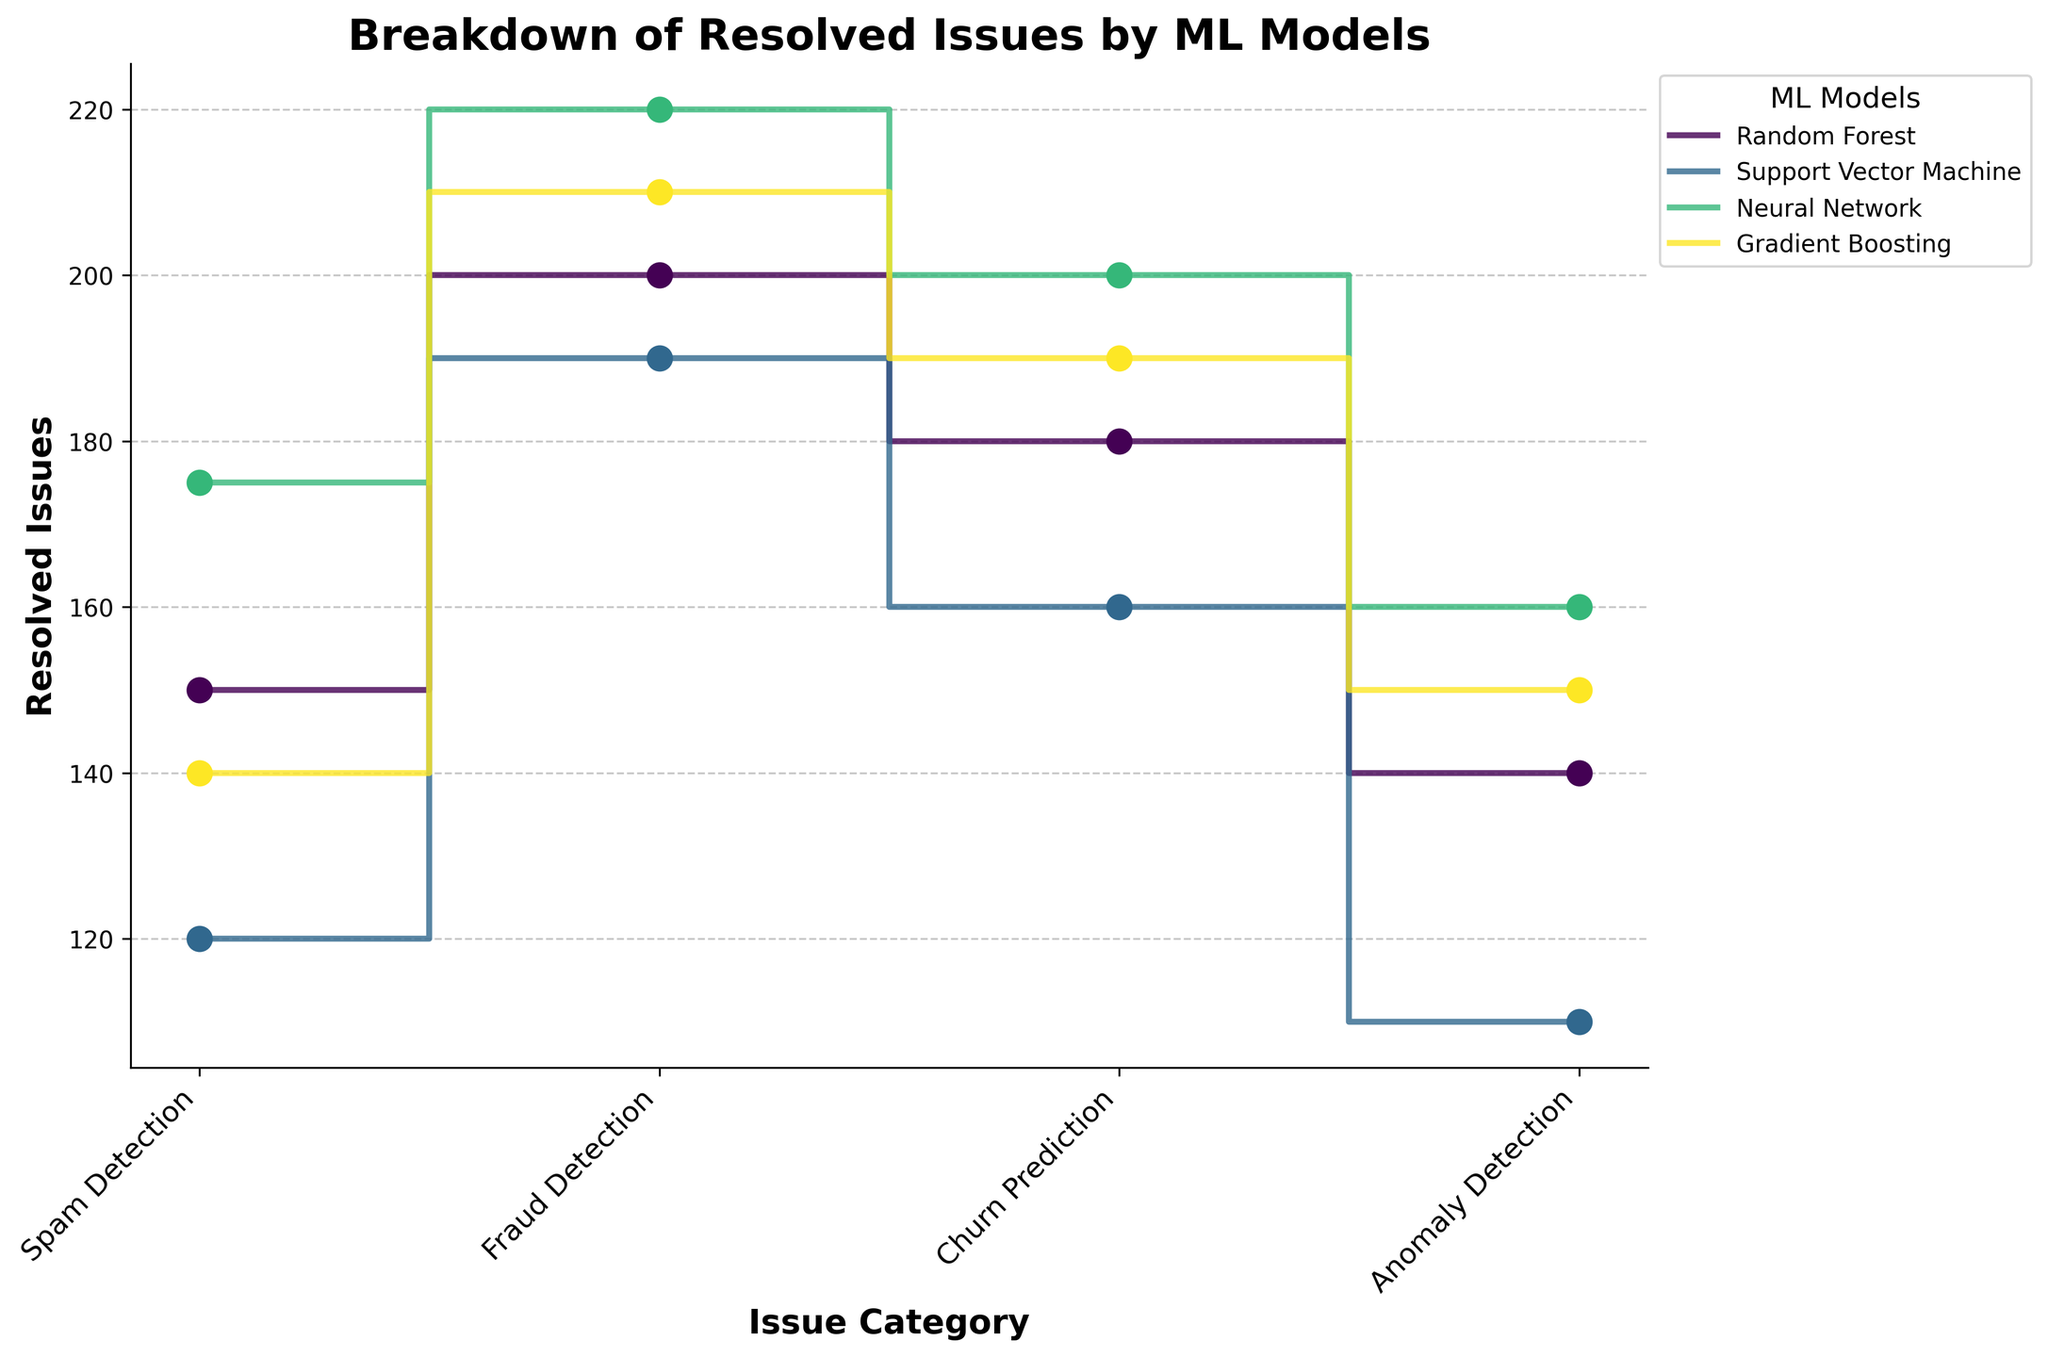What is the title of the figure? Look at the top center of the figure for the title.
Answer: Breakdown of Resolved Issues by ML Models Which machine learning model resolved the most spam detection issues? Compare the resolved spam detection issues for all models.
Answer: Neural Network How many resolved issues does the Support Vector Machine have for anomaly detection? Look at the step plot for Support Vector Machine and check the resolved issue count at the anomaly detection point.
Answer: 110 What is the total number of issues resolved by Gradient Boosting across all categories? Sum the resolved issues for Gradient Boosting in all categories (Spam Detection + Fraud Detection + Churn Prediction + Anomaly Detection).
Answer: 140 + 210 + 190 + 150 = 690 Which two models have resolved the same number of issues for spam detection? Check the step plots for spam detection across all models and identify any overlaps.
Answer: Random Forest and Gradient Boosting In which category does the Neural Network perform better than all other models? Compare the resolved issues for Neural Network with other models in each category.
Answer: Fraud Detection What is the difference in resolved fraud detection issues between Random Forest and Support Vector Machine? Subtract Support Vector Machine's fraud detection issues from Random Forest's fraud detection issues.
Answer: 200 - 190 = 10 If you sum the resolved issues for anomaly detection across all models, what is the total? Add the resolved issues for anomaly detection for all models.
Answer: 140 + 110 + 160 + 150 = 560 Which model has the least consistent performance across different issue categories? Look for the model with the greatest variance in the step heights across the categories.
Answer: Support Vector Machine How much more churn prediction issues did Neural Network resolve compared to Random Forest? Subtract Random Forest's churn prediction issues from Neural Network's churn prediction issues.
Answer: 200 - 180 = 20 